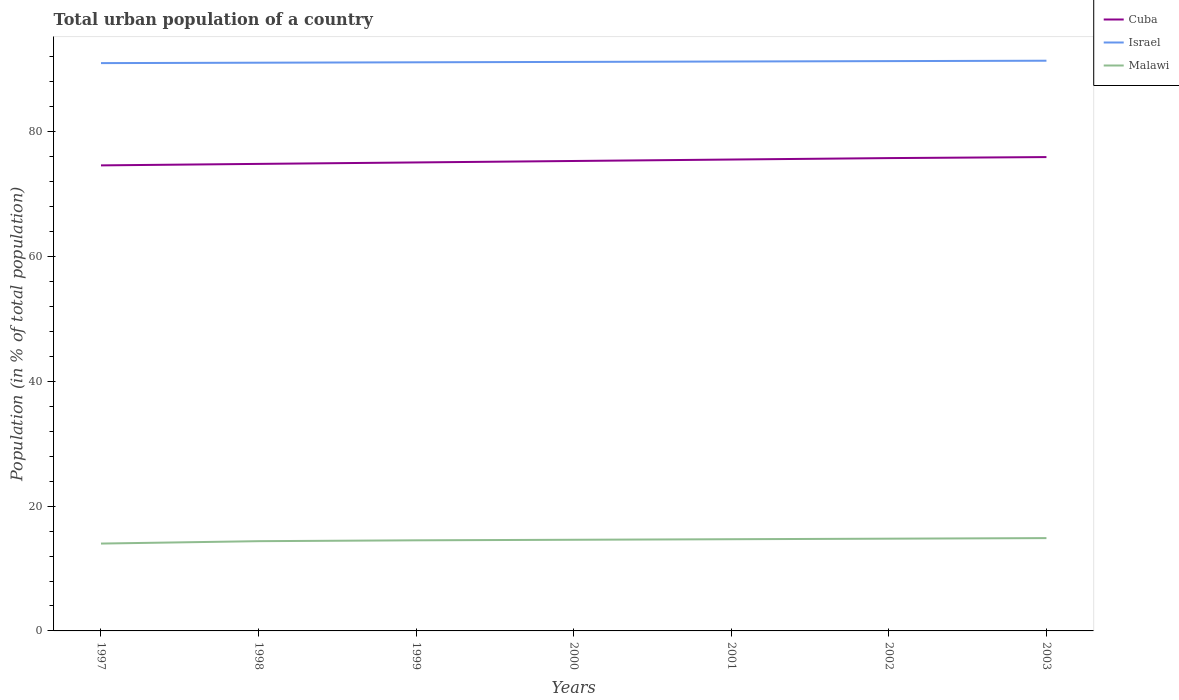How many different coloured lines are there?
Give a very brief answer. 3. Across all years, what is the maximum urban population in Malawi?
Provide a succinct answer. 14. In which year was the urban population in Israel maximum?
Your answer should be very brief. 1997. What is the total urban population in Israel in the graph?
Provide a succinct answer. -0.19. What is the difference between the highest and the second highest urban population in Israel?
Keep it short and to the point. 0.38. What is the difference between the highest and the lowest urban population in Israel?
Your answer should be compact. 4. Is the urban population in Cuba strictly greater than the urban population in Malawi over the years?
Give a very brief answer. No. How many lines are there?
Make the answer very short. 3. What is the difference between two consecutive major ticks on the Y-axis?
Give a very brief answer. 20. Does the graph contain grids?
Ensure brevity in your answer.  No. How many legend labels are there?
Offer a terse response. 3. What is the title of the graph?
Your response must be concise. Total urban population of a country. What is the label or title of the X-axis?
Offer a terse response. Years. What is the label or title of the Y-axis?
Provide a short and direct response. Population (in % of total population). What is the Population (in % of total population) in Cuba in 1997?
Ensure brevity in your answer.  74.62. What is the Population (in % of total population) in Israel in 1997?
Keep it short and to the point. 91.01. What is the Population (in % of total population) of Malawi in 1997?
Give a very brief answer. 14. What is the Population (in % of total population) in Cuba in 1998?
Your response must be concise. 74.86. What is the Population (in % of total population) in Israel in 1998?
Your answer should be very brief. 91.07. What is the Population (in % of total population) of Malawi in 1998?
Your answer should be compact. 14.38. What is the Population (in % of total population) of Cuba in 1999?
Offer a terse response. 75.09. What is the Population (in % of total population) of Israel in 1999?
Your answer should be compact. 91.14. What is the Population (in % of total population) of Malawi in 1999?
Give a very brief answer. 14.52. What is the Population (in % of total population) in Cuba in 2000?
Your answer should be very brief. 75.32. What is the Population (in % of total population) in Israel in 2000?
Your answer should be very brief. 91.2. What is the Population (in % of total population) in Malawi in 2000?
Make the answer very short. 14.61. What is the Population (in % of total population) of Cuba in 2001?
Offer a very short reply. 75.56. What is the Population (in % of total population) of Israel in 2001?
Provide a short and direct response. 91.27. What is the Population (in % of total population) of Malawi in 2001?
Keep it short and to the point. 14.7. What is the Population (in % of total population) of Cuba in 2002?
Offer a terse response. 75.78. What is the Population (in % of total population) of Israel in 2002?
Ensure brevity in your answer.  91.33. What is the Population (in % of total population) in Malawi in 2002?
Provide a short and direct response. 14.79. What is the Population (in % of total population) of Cuba in 2003?
Offer a very short reply. 75.95. What is the Population (in % of total population) in Israel in 2003?
Your answer should be very brief. 91.39. What is the Population (in % of total population) in Malawi in 2003?
Offer a very short reply. 14.88. Across all years, what is the maximum Population (in % of total population) in Cuba?
Your answer should be compact. 75.95. Across all years, what is the maximum Population (in % of total population) in Israel?
Provide a short and direct response. 91.39. Across all years, what is the maximum Population (in % of total population) of Malawi?
Provide a succinct answer. 14.88. Across all years, what is the minimum Population (in % of total population) of Cuba?
Provide a short and direct response. 74.62. Across all years, what is the minimum Population (in % of total population) in Israel?
Provide a succinct answer. 91.01. Across all years, what is the minimum Population (in % of total population) in Malawi?
Offer a terse response. 14. What is the total Population (in % of total population) of Cuba in the graph?
Offer a terse response. 527.17. What is the total Population (in % of total population) in Israel in the graph?
Your response must be concise. 638.41. What is the total Population (in % of total population) in Malawi in the graph?
Keep it short and to the point. 101.88. What is the difference between the Population (in % of total population) in Cuba in 1997 and that in 1998?
Keep it short and to the point. -0.24. What is the difference between the Population (in % of total population) in Israel in 1997 and that in 1998?
Ensure brevity in your answer.  -0.07. What is the difference between the Population (in % of total population) of Malawi in 1997 and that in 1998?
Make the answer very short. -0.38. What is the difference between the Population (in % of total population) in Cuba in 1997 and that in 1999?
Offer a very short reply. -0.47. What is the difference between the Population (in % of total population) of Israel in 1997 and that in 1999?
Keep it short and to the point. -0.13. What is the difference between the Population (in % of total population) of Malawi in 1997 and that in 1999?
Provide a short and direct response. -0.52. What is the difference between the Population (in % of total population) of Cuba in 1997 and that in 2000?
Offer a terse response. -0.7. What is the difference between the Population (in % of total population) in Israel in 1997 and that in 2000?
Make the answer very short. -0.19. What is the difference between the Population (in % of total population) of Malawi in 1997 and that in 2000?
Your response must be concise. -0.61. What is the difference between the Population (in % of total population) of Cuba in 1997 and that in 2001?
Make the answer very short. -0.94. What is the difference between the Population (in % of total population) of Israel in 1997 and that in 2001?
Keep it short and to the point. -0.26. What is the difference between the Population (in % of total population) in Malawi in 1997 and that in 2001?
Make the answer very short. -0.7. What is the difference between the Population (in % of total population) of Cuba in 1997 and that in 2002?
Offer a terse response. -1.17. What is the difference between the Population (in % of total population) in Israel in 1997 and that in 2002?
Offer a terse response. -0.32. What is the difference between the Population (in % of total population) of Malawi in 1997 and that in 2002?
Keep it short and to the point. -0.78. What is the difference between the Population (in % of total population) in Cuba in 1997 and that in 2003?
Your answer should be very brief. -1.33. What is the difference between the Population (in % of total population) in Israel in 1997 and that in 2003?
Provide a succinct answer. -0.38. What is the difference between the Population (in % of total population) in Malawi in 1997 and that in 2003?
Your answer should be compact. -0.87. What is the difference between the Population (in % of total population) in Cuba in 1998 and that in 1999?
Make the answer very short. -0.23. What is the difference between the Population (in % of total population) of Israel in 1998 and that in 1999?
Offer a very short reply. -0.07. What is the difference between the Population (in % of total population) in Malawi in 1998 and that in 1999?
Provide a short and direct response. -0.14. What is the difference between the Population (in % of total population) in Cuba in 1998 and that in 2000?
Ensure brevity in your answer.  -0.47. What is the difference between the Population (in % of total population) of Israel in 1998 and that in 2000?
Your answer should be very brief. -0.13. What is the difference between the Population (in % of total population) of Malawi in 1998 and that in 2000?
Give a very brief answer. -0.23. What is the difference between the Population (in % of total population) of Israel in 1998 and that in 2001?
Ensure brevity in your answer.  -0.19. What is the difference between the Population (in % of total population) of Malawi in 1998 and that in 2001?
Your answer should be very brief. -0.31. What is the difference between the Population (in % of total population) of Cuba in 1998 and that in 2002?
Keep it short and to the point. -0.93. What is the difference between the Population (in % of total population) in Israel in 1998 and that in 2002?
Provide a short and direct response. -0.26. What is the difference between the Population (in % of total population) in Malawi in 1998 and that in 2002?
Offer a terse response. -0.4. What is the difference between the Population (in % of total population) in Cuba in 1998 and that in 2003?
Give a very brief answer. -1.09. What is the difference between the Population (in % of total population) in Israel in 1998 and that in 2003?
Provide a succinct answer. -0.32. What is the difference between the Population (in % of total population) in Malawi in 1998 and that in 2003?
Keep it short and to the point. -0.49. What is the difference between the Population (in % of total population) in Cuba in 1999 and that in 2000?
Your response must be concise. -0.23. What is the difference between the Population (in % of total population) in Israel in 1999 and that in 2000?
Your answer should be compact. -0.06. What is the difference between the Population (in % of total population) of Malawi in 1999 and that in 2000?
Give a very brief answer. -0.09. What is the difference between the Population (in % of total population) of Cuba in 1999 and that in 2001?
Give a very brief answer. -0.47. What is the difference between the Population (in % of total population) of Israel in 1999 and that in 2001?
Your answer should be compact. -0.13. What is the difference between the Population (in % of total population) in Malawi in 1999 and that in 2001?
Offer a very short reply. -0.18. What is the difference between the Population (in % of total population) of Cuba in 1999 and that in 2002?
Ensure brevity in your answer.  -0.7. What is the difference between the Population (in % of total population) in Israel in 1999 and that in 2002?
Provide a succinct answer. -0.19. What is the difference between the Population (in % of total population) in Malawi in 1999 and that in 2002?
Your answer should be compact. -0.26. What is the difference between the Population (in % of total population) in Cuba in 1999 and that in 2003?
Keep it short and to the point. -0.86. What is the difference between the Population (in % of total population) in Israel in 1999 and that in 2003?
Your answer should be compact. -0.25. What is the difference between the Population (in % of total population) of Malawi in 1999 and that in 2003?
Offer a terse response. -0.35. What is the difference between the Population (in % of total population) of Cuba in 2000 and that in 2001?
Provide a succinct answer. -0.23. What is the difference between the Population (in % of total population) in Israel in 2000 and that in 2001?
Offer a very short reply. -0.06. What is the difference between the Population (in % of total population) of Malawi in 2000 and that in 2001?
Keep it short and to the point. -0.09. What is the difference between the Population (in % of total population) in Cuba in 2000 and that in 2002?
Provide a short and direct response. -0.46. What is the difference between the Population (in % of total population) of Israel in 2000 and that in 2002?
Ensure brevity in your answer.  -0.13. What is the difference between the Population (in % of total population) in Malawi in 2000 and that in 2002?
Offer a very short reply. -0.18. What is the difference between the Population (in % of total population) of Cuba in 2000 and that in 2003?
Your answer should be very brief. -0.62. What is the difference between the Population (in % of total population) in Israel in 2000 and that in 2003?
Make the answer very short. -0.19. What is the difference between the Population (in % of total population) of Malawi in 2000 and that in 2003?
Provide a succinct answer. -0.27. What is the difference between the Population (in % of total population) in Cuba in 2001 and that in 2002?
Provide a short and direct response. -0.23. What is the difference between the Population (in % of total population) of Israel in 2001 and that in 2002?
Your response must be concise. -0.06. What is the difference between the Population (in % of total population) of Malawi in 2001 and that in 2002?
Your answer should be very brief. -0.09. What is the difference between the Population (in % of total population) of Cuba in 2001 and that in 2003?
Your answer should be very brief. -0.39. What is the difference between the Population (in % of total population) of Israel in 2001 and that in 2003?
Your answer should be very brief. -0.13. What is the difference between the Population (in % of total population) in Malawi in 2001 and that in 2003?
Your response must be concise. -0.18. What is the difference between the Population (in % of total population) of Cuba in 2002 and that in 2003?
Your response must be concise. -0.16. What is the difference between the Population (in % of total population) in Israel in 2002 and that in 2003?
Ensure brevity in your answer.  -0.06. What is the difference between the Population (in % of total population) of Malawi in 2002 and that in 2003?
Your response must be concise. -0.09. What is the difference between the Population (in % of total population) of Cuba in 1997 and the Population (in % of total population) of Israel in 1998?
Offer a very short reply. -16.46. What is the difference between the Population (in % of total population) of Cuba in 1997 and the Population (in % of total population) of Malawi in 1998?
Offer a terse response. 60.23. What is the difference between the Population (in % of total population) of Israel in 1997 and the Population (in % of total population) of Malawi in 1998?
Provide a short and direct response. 76.62. What is the difference between the Population (in % of total population) in Cuba in 1997 and the Population (in % of total population) in Israel in 1999?
Offer a terse response. -16.52. What is the difference between the Population (in % of total population) of Cuba in 1997 and the Population (in % of total population) of Malawi in 1999?
Give a very brief answer. 60.1. What is the difference between the Population (in % of total population) of Israel in 1997 and the Population (in % of total population) of Malawi in 1999?
Your response must be concise. 76.49. What is the difference between the Population (in % of total population) in Cuba in 1997 and the Population (in % of total population) in Israel in 2000?
Keep it short and to the point. -16.59. What is the difference between the Population (in % of total population) in Cuba in 1997 and the Population (in % of total population) in Malawi in 2000?
Provide a succinct answer. 60.01. What is the difference between the Population (in % of total population) of Israel in 1997 and the Population (in % of total population) of Malawi in 2000?
Your response must be concise. 76.4. What is the difference between the Population (in % of total population) of Cuba in 1997 and the Population (in % of total population) of Israel in 2001?
Your response must be concise. -16.65. What is the difference between the Population (in % of total population) in Cuba in 1997 and the Population (in % of total population) in Malawi in 2001?
Give a very brief answer. 59.92. What is the difference between the Population (in % of total population) in Israel in 1997 and the Population (in % of total population) in Malawi in 2001?
Your answer should be very brief. 76.31. What is the difference between the Population (in % of total population) in Cuba in 1997 and the Population (in % of total population) in Israel in 2002?
Provide a short and direct response. -16.71. What is the difference between the Population (in % of total population) of Cuba in 1997 and the Population (in % of total population) of Malawi in 2002?
Make the answer very short. 59.83. What is the difference between the Population (in % of total population) of Israel in 1997 and the Population (in % of total population) of Malawi in 2002?
Make the answer very short. 76.22. What is the difference between the Population (in % of total population) in Cuba in 1997 and the Population (in % of total population) in Israel in 2003?
Your answer should be compact. -16.77. What is the difference between the Population (in % of total population) of Cuba in 1997 and the Population (in % of total population) of Malawi in 2003?
Provide a succinct answer. 59.74. What is the difference between the Population (in % of total population) in Israel in 1997 and the Population (in % of total population) in Malawi in 2003?
Keep it short and to the point. 76.13. What is the difference between the Population (in % of total population) of Cuba in 1998 and the Population (in % of total population) of Israel in 1999?
Your answer should be very brief. -16.28. What is the difference between the Population (in % of total population) of Cuba in 1998 and the Population (in % of total population) of Malawi in 1999?
Your answer should be very brief. 60.33. What is the difference between the Population (in % of total population) of Israel in 1998 and the Population (in % of total population) of Malawi in 1999?
Your answer should be very brief. 76.55. What is the difference between the Population (in % of total population) in Cuba in 1998 and the Population (in % of total population) in Israel in 2000?
Give a very brief answer. -16.35. What is the difference between the Population (in % of total population) of Cuba in 1998 and the Population (in % of total population) of Malawi in 2000?
Make the answer very short. 60.24. What is the difference between the Population (in % of total population) of Israel in 1998 and the Population (in % of total population) of Malawi in 2000?
Your answer should be compact. 76.46. What is the difference between the Population (in % of total population) of Cuba in 1998 and the Population (in % of total population) of Israel in 2001?
Your answer should be very brief. -16.41. What is the difference between the Population (in % of total population) of Cuba in 1998 and the Population (in % of total population) of Malawi in 2001?
Your answer should be very brief. 60.16. What is the difference between the Population (in % of total population) of Israel in 1998 and the Population (in % of total population) of Malawi in 2001?
Make the answer very short. 76.38. What is the difference between the Population (in % of total population) of Cuba in 1998 and the Population (in % of total population) of Israel in 2002?
Your response must be concise. -16.48. What is the difference between the Population (in % of total population) in Cuba in 1998 and the Population (in % of total population) in Malawi in 2002?
Make the answer very short. 60.07. What is the difference between the Population (in % of total population) of Israel in 1998 and the Population (in % of total population) of Malawi in 2002?
Your response must be concise. 76.29. What is the difference between the Population (in % of total population) of Cuba in 1998 and the Population (in % of total population) of Israel in 2003?
Offer a very short reply. -16.54. What is the difference between the Population (in % of total population) of Cuba in 1998 and the Population (in % of total population) of Malawi in 2003?
Keep it short and to the point. 59.98. What is the difference between the Population (in % of total population) of Israel in 1998 and the Population (in % of total population) of Malawi in 2003?
Keep it short and to the point. 76.2. What is the difference between the Population (in % of total population) of Cuba in 1999 and the Population (in % of total population) of Israel in 2000?
Provide a succinct answer. -16.11. What is the difference between the Population (in % of total population) of Cuba in 1999 and the Population (in % of total population) of Malawi in 2000?
Keep it short and to the point. 60.48. What is the difference between the Population (in % of total population) of Israel in 1999 and the Population (in % of total population) of Malawi in 2000?
Your answer should be very brief. 76.53. What is the difference between the Population (in % of total population) of Cuba in 1999 and the Population (in % of total population) of Israel in 2001?
Make the answer very short. -16.18. What is the difference between the Population (in % of total population) of Cuba in 1999 and the Population (in % of total population) of Malawi in 2001?
Ensure brevity in your answer.  60.39. What is the difference between the Population (in % of total population) of Israel in 1999 and the Population (in % of total population) of Malawi in 2001?
Make the answer very short. 76.44. What is the difference between the Population (in % of total population) in Cuba in 1999 and the Population (in % of total population) in Israel in 2002?
Provide a succinct answer. -16.24. What is the difference between the Population (in % of total population) in Cuba in 1999 and the Population (in % of total population) in Malawi in 2002?
Your response must be concise. 60.3. What is the difference between the Population (in % of total population) in Israel in 1999 and the Population (in % of total population) in Malawi in 2002?
Your answer should be compact. 76.35. What is the difference between the Population (in % of total population) of Cuba in 1999 and the Population (in % of total population) of Israel in 2003?
Keep it short and to the point. -16.3. What is the difference between the Population (in % of total population) of Cuba in 1999 and the Population (in % of total population) of Malawi in 2003?
Keep it short and to the point. 60.21. What is the difference between the Population (in % of total population) in Israel in 1999 and the Population (in % of total population) in Malawi in 2003?
Provide a short and direct response. 76.26. What is the difference between the Population (in % of total population) in Cuba in 2000 and the Population (in % of total population) in Israel in 2001?
Your answer should be compact. -15.94. What is the difference between the Population (in % of total population) of Cuba in 2000 and the Population (in % of total population) of Malawi in 2001?
Offer a very short reply. 60.62. What is the difference between the Population (in % of total population) of Israel in 2000 and the Population (in % of total population) of Malawi in 2001?
Your response must be concise. 76.5. What is the difference between the Population (in % of total population) in Cuba in 2000 and the Population (in % of total population) in Israel in 2002?
Offer a terse response. -16.01. What is the difference between the Population (in % of total population) in Cuba in 2000 and the Population (in % of total population) in Malawi in 2002?
Provide a succinct answer. 60.54. What is the difference between the Population (in % of total population) in Israel in 2000 and the Population (in % of total population) in Malawi in 2002?
Give a very brief answer. 76.42. What is the difference between the Population (in % of total population) of Cuba in 2000 and the Population (in % of total population) of Israel in 2003?
Keep it short and to the point. -16.07. What is the difference between the Population (in % of total population) in Cuba in 2000 and the Population (in % of total population) in Malawi in 2003?
Your response must be concise. 60.45. What is the difference between the Population (in % of total population) of Israel in 2000 and the Population (in % of total population) of Malawi in 2003?
Keep it short and to the point. 76.33. What is the difference between the Population (in % of total population) of Cuba in 2001 and the Population (in % of total population) of Israel in 2002?
Your answer should be very brief. -15.78. What is the difference between the Population (in % of total population) of Cuba in 2001 and the Population (in % of total population) of Malawi in 2002?
Keep it short and to the point. 60.77. What is the difference between the Population (in % of total population) of Israel in 2001 and the Population (in % of total population) of Malawi in 2002?
Ensure brevity in your answer.  76.48. What is the difference between the Population (in % of total population) of Cuba in 2001 and the Population (in % of total population) of Israel in 2003?
Make the answer very short. -15.84. What is the difference between the Population (in % of total population) of Cuba in 2001 and the Population (in % of total population) of Malawi in 2003?
Your response must be concise. 60.68. What is the difference between the Population (in % of total population) in Israel in 2001 and the Population (in % of total population) in Malawi in 2003?
Your answer should be very brief. 76.39. What is the difference between the Population (in % of total population) in Cuba in 2002 and the Population (in % of total population) in Israel in 2003?
Your response must be concise. -15.61. What is the difference between the Population (in % of total population) in Cuba in 2002 and the Population (in % of total population) in Malawi in 2003?
Give a very brief answer. 60.91. What is the difference between the Population (in % of total population) in Israel in 2002 and the Population (in % of total population) in Malawi in 2003?
Your answer should be very brief. 76.45. What is the average Population (in % of total population) of Cuba per year?
Your answer should be very brief. 75.31. What is the average Population (in % of total population) in Israel per year?
Your response must be concise. 91.2. What is the average Population (in % of total population) of Malawi per year?
Your answer should be very brief. 14.55. In the year 1997, what is the difference between the Population (in % of total population) in Cuba and Population (in % of total population) in Israel?
Give a very brief answer. -16.39. In the year 1997, what is the difference between the Population (in % of total population) in Cuba and Population (in % of total population) in Malawi?
Provide a short and direct response. 60.62. In the year 1997, what is the difference between the Population (in % of total population) in Israel and Population (in % of total population) in Malawi?
Make the answer very short. 77.01. In the year 1998, what is the difference between the Population (in % of total population) in Cuba and Population (in % of total population) in Israel?
Your answer should be very brief. -16.22. In the year 1998, what is the difference between the Population (in % of total population) of Cuba and Population (in % of total population) of Malawi?
Keep it short and to the point. 60.47. In the year 1998, what is the difference between the Population (in % of total population) of Israel and Population (in % of total population) of Malawi?
Keep it short and to the point. 76.69. In the year 1999, what is the difference between the Population (in % of total population) of Cuba and Population (in % of total population) of Israel?
Provide a short and direct response. -16.05. In the year 1999, what is the difference between the Population (in % of total population) of Cuba and Population (in % of total population) of Malawi?
Your response must be concise. 60.57. In the year 1999, what is the difference between the Population (in % of total population) of Israel and Population (in % of total population) of Malawi?
Ensure brevity in your answer.  76.62. In the year 2000, what is the difference between the Population (in % of total population) of Cuba and Population (in % of total population) of Israel?
Give a very brief answer. -15.88. In the year 2000, what is the difference between the Population (in % of total population) of Cuba and Population (in % of total population) of Malawi?
Your answer should be very brief. 60.71. In the year 2000, what is the difference between the Population (in % of total population) of Israel and Population (in % of total population) of Malawi?
Your answer should be compact. 76.59. In the year 2001, what is the difference between the Population (in % of total population) in Cuba and Population (in % of total population) in Israel?
Your answer should be compact. -15.71. In the year 2001, what is the difference between the Population (in % of total population) in Cuba and Population (in % of total population) in Malawi?
Offer a terse response. 60.86. In the year 2001, what is the difference between the Population (in % of total population) in Israel and Population (in % of total population) in Malawi?
Ensure brevity in your answer.  76.57. In the year 2002, what is the difference between the Population (in % of total population) in Cuba and Population (in % of total population) in Israel?
Your response must be concise. -15.54. In the year 2002, what is the difference between the Population (in % of total population) in Cuba and Population (in % of total population) in Malawi?
Your response must be concise. 61. In the year 2002, what is the difference between the Population (in % of total population) in Israel and Population (in % of total population) in Malawi?
Your answer should be compact. 76.54. In the year 2003, what is the difference between the Population (in % of total population) of Cuba and Population (in % of total population) of Israel?
Your response must be concise. -15.45. In the year 2003, what is the difference between the Population (in % of total population) in Cuba and Population (in % of total population) in Malawi?
Your response must be concise. 61.07. In the year 2003, what is the difference between the Population (in % of total population) of Israel and Population (in % of total population) of Malawi?
Provide a succinct answer. 76.52. What is the ratio of the Population (in % of total population) in Malawi in 1997 to that in 1998?
Provide a succinct answer. 0.97. What is the ratio of the Population (in % of total population) of Malawi in 1997 to that in 1999?
Your answer should be compact. 0.96. What is the ratio of the Population (in % of total population) in Cuba in 1997 to that in 2000?
Provide a short and direct response. 0.99. What is the ratio of the Population (in % of total population) of Malawi in 1997 to that in 2000?
Your response must be concise. 0.96. What is the ratio of the Population (in % of total population) in Cuba in 1997 to that in 2001?
Provide a succinct answer. 0.99. What is the ratio of the Population (in % of total population) of Malawi in 1997 to that in 2001?
Keep it short and to the point. 0.95. What is the ratio of the Population (in % of total population) of Cuba in 1997 to that in 2002?
Your response must be concise. 0.98. What is the ratio of the Population (in % of total population) of Israel in 1997 to that in 2002?
Keep it short and to the point. 1. What is the ratio of the Population (in % of total population) of Malawi in 1997 to that in 2002?
Provide a short and direct response. 0.95. What is the ratio of the Population (in % of total population) in Cuba in 1997 to that in 2003?
Ensure brevity in your answer.  0.98. What is the ratio of the Population (in % of total population) in Israel in 1997 to that in 2003?
Provide a short and direct response. 1. What is the ratio of the Population (in % of total population) of Malawi in 1997 to that in 2003?
Give a very brief answer. 0.94. What is the ratio of the Population (in % of total population) in Cuba in 1998 to that in 1999?
Provide a short and direct response. 1. What is the ratio of the Population (in % of total population) in Israel in 1998 to that in 2000?
Your answer should be very brief. 1. What is the ratio of the Population (in % of total population) of Malawi in 1998 to that in 2000?
Give a very brief answer. 0.98. What is the ratio of the Population (in % of total population) of Cuba in 1998 to that in 2001?
Keep it short and to the point. 0.99. What is the ratio of the Population (in % of total population) in Israel in 1998 to that in 2001?
Keep it short and to the point. 1. What is the ratio of the Population (in % of total population) of Malawi in 1998 to that in 2001?
Ensure brevity in your answer.  0.98. What is the ratio of the Population (in % of total population) of Malawi in 1998 to that in 2002?
Provide a succinct answer. 0.97. What is the ratio of the Population (in % of total population) of Cuba in 1998 to that in 2003?
Ensure brevity in your answer.  0.99. What is the ratio of the Population (in % of total population) in Malawi in 1998 to that in 2003?
Make the answer very short. 0.97. What is the ratio of the Population (in % of total population) of Cuba in 1999 to that in 2001?
Offer a terse response. 0.99. What is the ratio of the Population (in % of total population) in Israel in 1999 to that in 2001?
Your response must be concise. 1. What is the ratio of the Population (in % of total population) of Israel in 1999 to that in 2002?
Provide a succinct answer. 1. What is the ratio of the Population (in % of total population) of Malawi in 1999 to that in 2002?
Your response must be concise. 0.98. What is the ratio of the Population (in % of total population) of Cuba in 1999 to that in 2003?
Offer a very short reply. 0.99. What is the ratio of the Population (in % of total population) of Malawi in 1999 to that in 2003?
Give a very brief answer. 0.98. What is the ratio of the Population (in % of total population) in Cuba in 2000 to that in 2001?
Provide a short and direct response. 1. What is the ratio of the Population (in % of total population) in Israel in 2000 to that in 2001?
Your response must be concise. 1. What is the ratio of the Population (in % of total population) of Cuba in 2000 to that in 2003?
Provide a succinct answer. 0.99. What is the ratio of the Population (in % of total population) in Israel in 2000 to that in 2003?
Offer a very short reply. 1. What is the ratio of the Population (in % of total population) in Malawi in 2000 to that in 2003?
Keep it short and to the point. 0.98. What is the ratio of the Population (in % of total population) in Cuba in 2001 to that in 2002?
Your answer should be compact. 1. What is the ratio of the Population (in % of total population) in Cuba in 2001 to that in 2003?
Your response must be concise. 0.99. What is the ratio of the Population (in % of total population) of Malawi in 2001 to that in 2003?
Ensure brevity in your answer.  0.99. What is the ratio of the Population (in % of total population) of Israel in 2002 to that in 2003?
Offer a very short reply. 1. What is the difference between the highest and the second highest Population (in % of total population) of Cuba?
Provide a succinct answer. 0.16. What is the difference between the highest and the second highest Population (in % of total population) of Israel?
Your answer should be compact. 0.06. What is the difference between the highest and the second highest Population (in % of total population) of Malawi?
Your response must be concise. 0.09. What is the difference between the highest and the lowest Population (in % of total population) of Cuba?
Provide a short and direct response. 1.33. What is the difference between the highest and the lowest Population (in % of total population) in Israel?
Provide a succinct answer. 0.38. What is the difference between the highest and the lowest Population (in % of total population) of Malawi?
Your answer should be very brief. 0.87. 